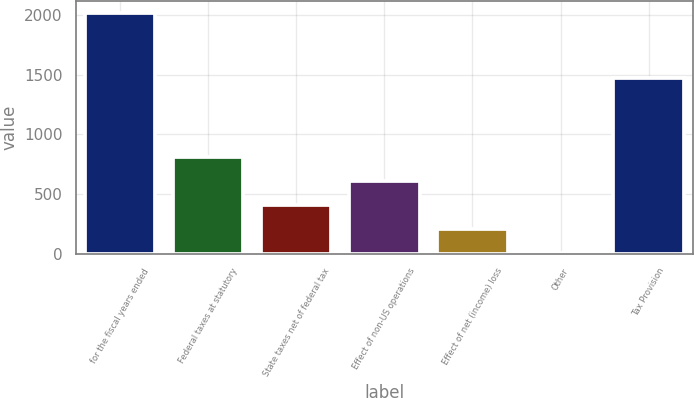Convert chart to OTSL. <chart><loc_0><loc_0><loc_500><loc_500><bar_chart><fcel>for the fiscal years ended<fcel>Federal taxes at statutory<fcel>State taxes net of federal tax<fcel>Effect of non-US operations<fcel>Effect of net (income) loss<fcel>Other<fcel>Tax Provision<nl><fcel>2018<fcel>807.8<fcel>404.4<fcel>606.1<fcel>202.7<fcel>1<fcel>1472.5<nl></chart> 